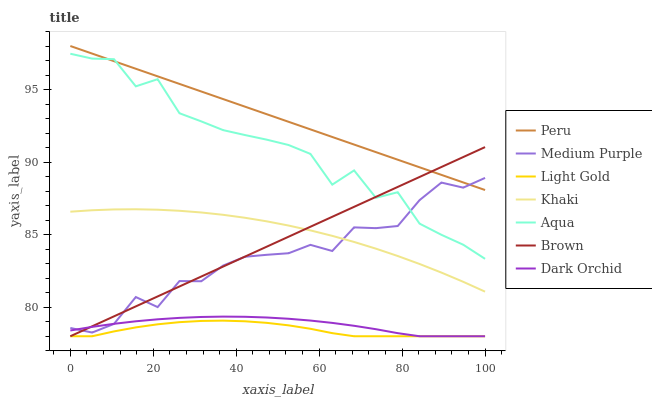Does Light Gold have the minimum area under the curve?
Answer yes or no. Yes. Does Peru have the maximum area under the curve?
Answer yes or no. Yes. Does Khaki have the minimum area under the curve?
Answer yes or no. No. Does Khaki have the maximum area under the curve?
Answer yes or no. No. Is Peru the smoothest?
Answer yes or no. Yes. Is Aqua the roughest?
Answer yes or no. Yes. Is Khaki the smoothest?
Answer yes or no. No. Is Khaki the roughest?
Answer yes or no. No. Does Brown have the lowest value?
Answer yes or no. Yes. Does Khaki have the lowest value?
Answer yes or no. No. Does Peru have the highest value?
Answer yes or no. Yes. Does Khaki have the highest value?
Answer yes or no. No. Is Light Gold less than Medium Purple?
Answer yes or no. Yes. Is Peru greater than Dark Orchid?
Answer yes or no. Yes. Does Brown intersect Dark Orchid?
Answer yes or no. Yes. Is Brown less than Dark Orchid?
Answer yes or no. No. Is Brown greater than Dark Orchid?
Answer yes or no. No. Does Light Gold intersect Medium Purple?
Answer yes or no. No. 